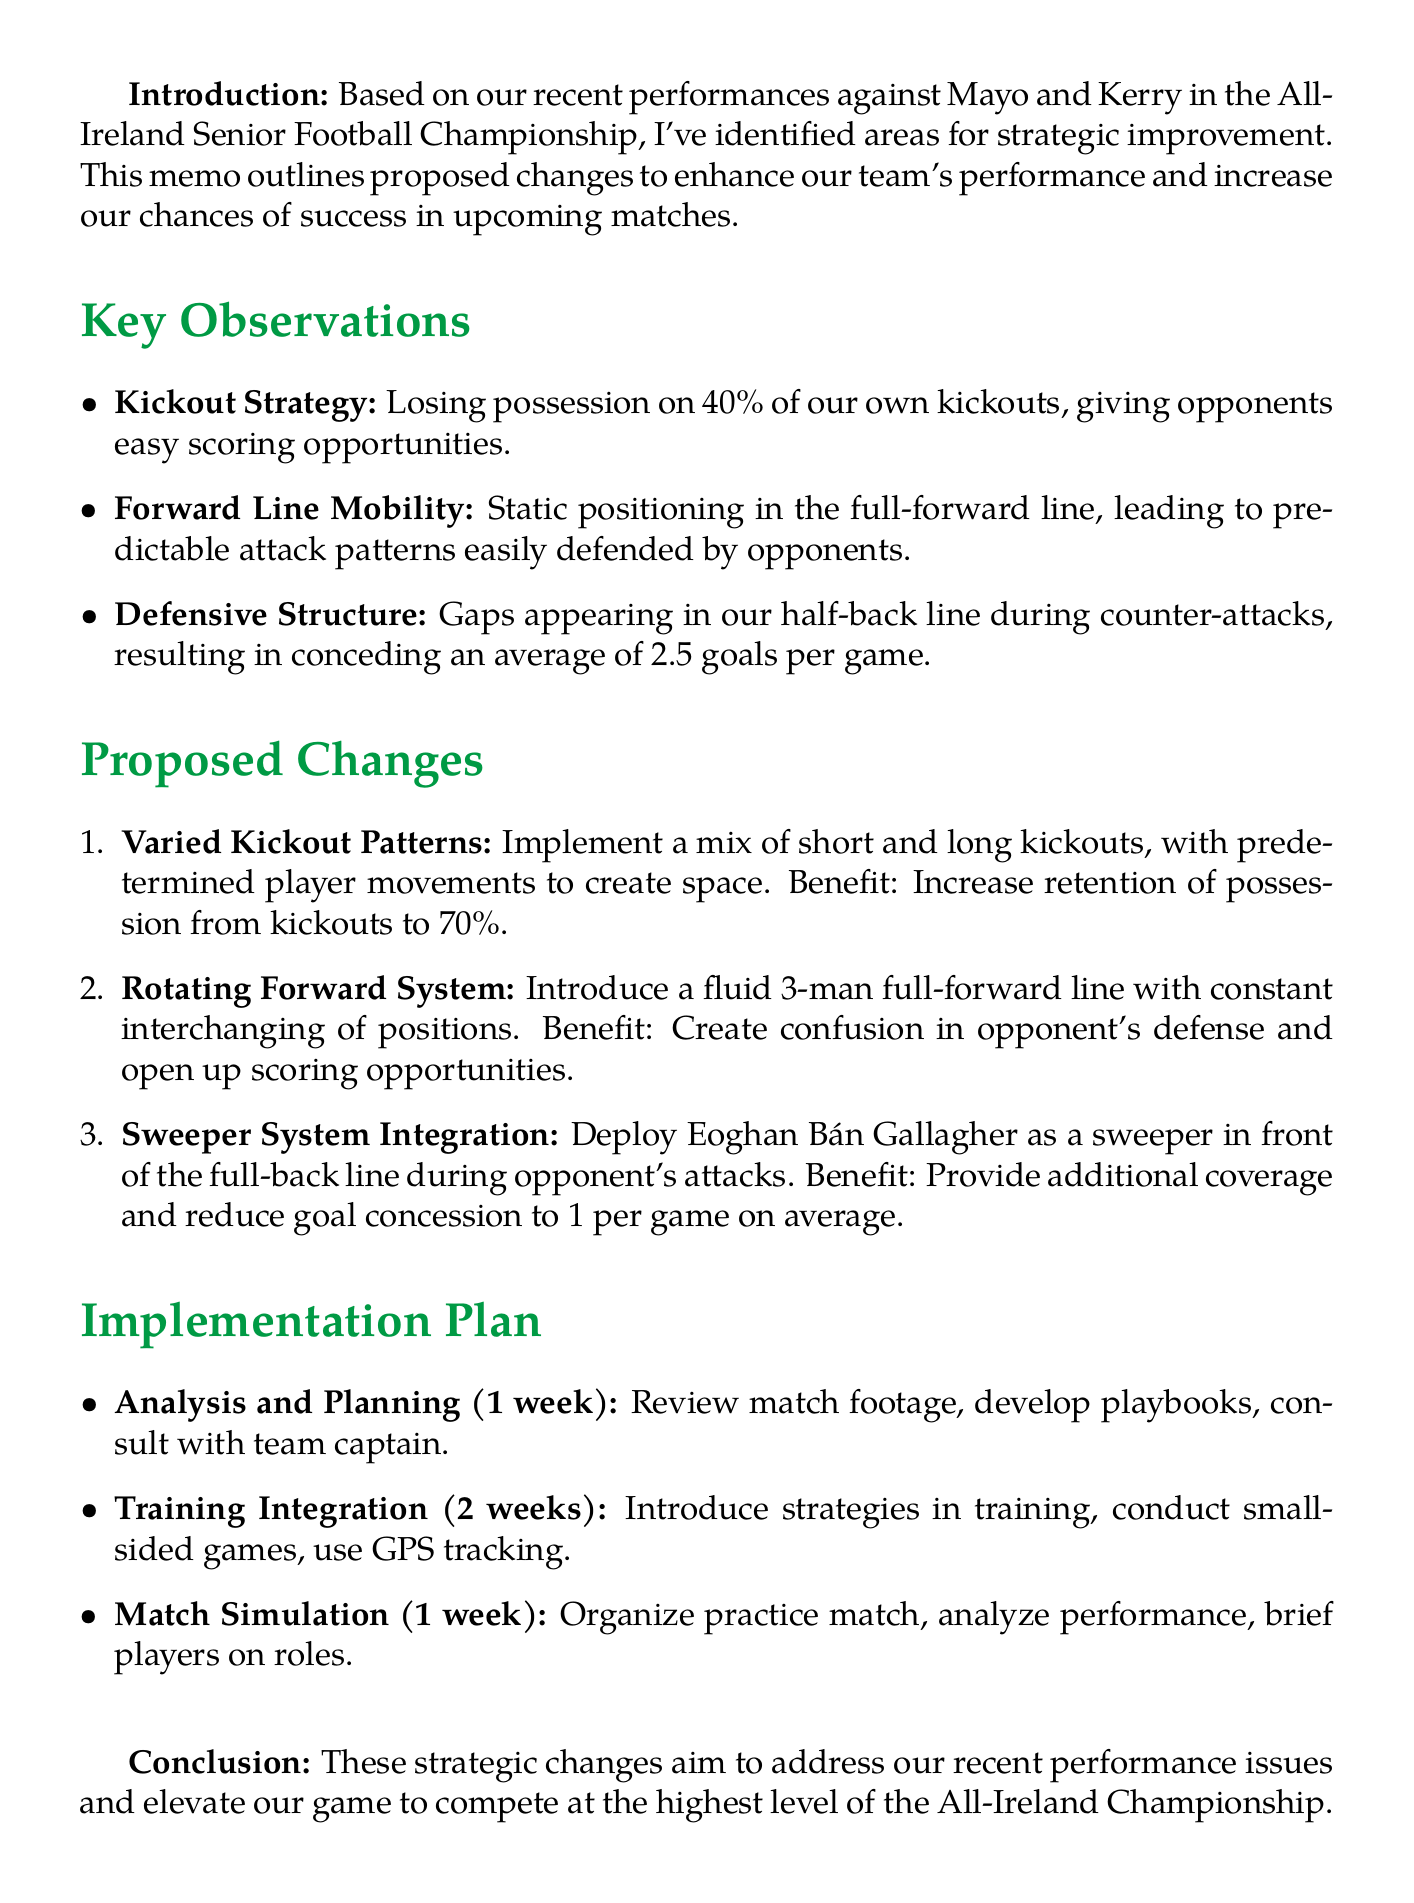What is the title of the memo? The title is explicitly stated at the beginning of the document.
Answer: Proposed Changes to Team Strategy for Donegal GAA Who is the author of the memo? The author is identified at the end of the document.
Answer: Declan Bonner What percentage of kickouts are we losing possession on? The document specifies a percentage related to kickouts.
Answer: 40% What is the proposed retention of possession from kickouts after changes? This is mentioned in the proposed changes section related to kickout strategy.
Answer: 70% How long is the Analysis and Planning phase scheduled for? The duration of this phase is given in the implementation plan.
Answer: 1 week Who is suggested to be deployed as a sweeper? The document provides the name of the player intended for the sweeper role.
Answer: Eoghan Bán Gallagher What is the average number of goals conceded per game currently? The document provides a statistic related to goals conceded.
Answer: 2.5 goals What is one of the activities planned during Training Integration? The implementation plan mentions specific activities for this phase.
Answer: Introduce new strategies in controlled training sessions What is the expected benefit of the Rotating Forward System? The document lists the anticipated benefits of the new strategies.
Answer: Create confusion in opponent's defense and open up scoring opportunities 